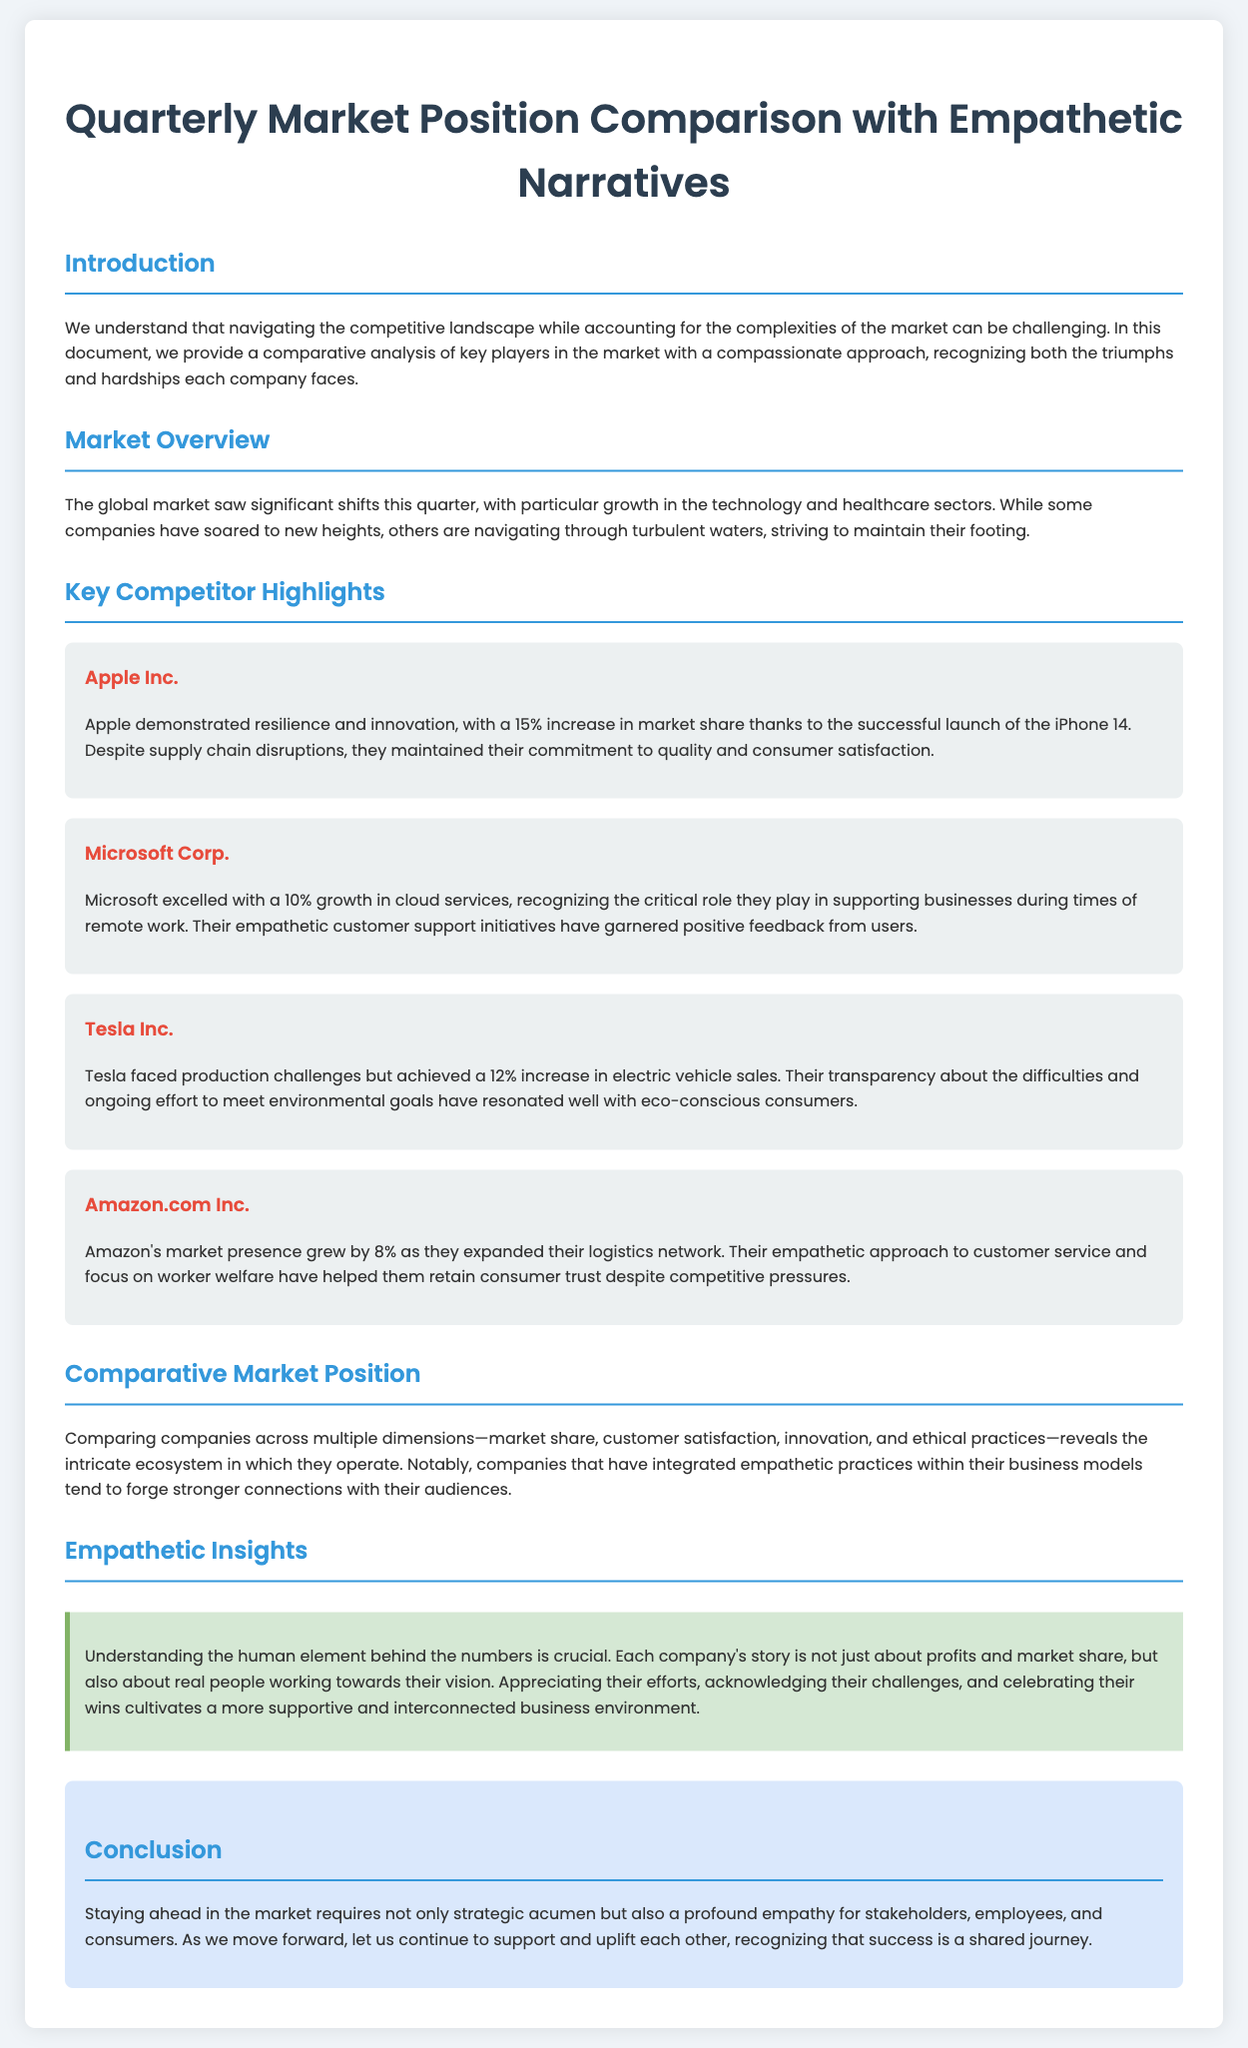What is the title of the document? The title of the document is presented in the header section of the document.
Answer: Quarterly Market Position Comparison with Empathetic Narratives How much did Apple Inc.'s market share increase? The increase in Apple Inc.'s market share is explicitly stated in their section of the document.
Answer: 15% What was Microsoft's growth percentage in cloud services? This information can be found in the section discussing Microsoft Corp.
Answer: 10% What key theme is emphasized in the "Empathetic Insights" section? The key theme discussed in the "Empathetic Insights" section focuses on the human element behind the companies' performances.
Answer: Human element Which company achieved a 12% increase in electric vehicle sales? This detail is mentioned in the section about Tesla Inc.
Answer: Tesla Inc How do empathetic practices affect companies according to the document? This question requires synthesizing information from the comparative analysis discussed in the document.
Answer: Stronger connections What is the purpose of the "Conclusion" section? The conclusion summarizes the main message of the document.
Answer: Support and uplift each other Which sector saw significant growth this quarter? This information is found in the Market Overview section.
Answer: Technology and healthcare 